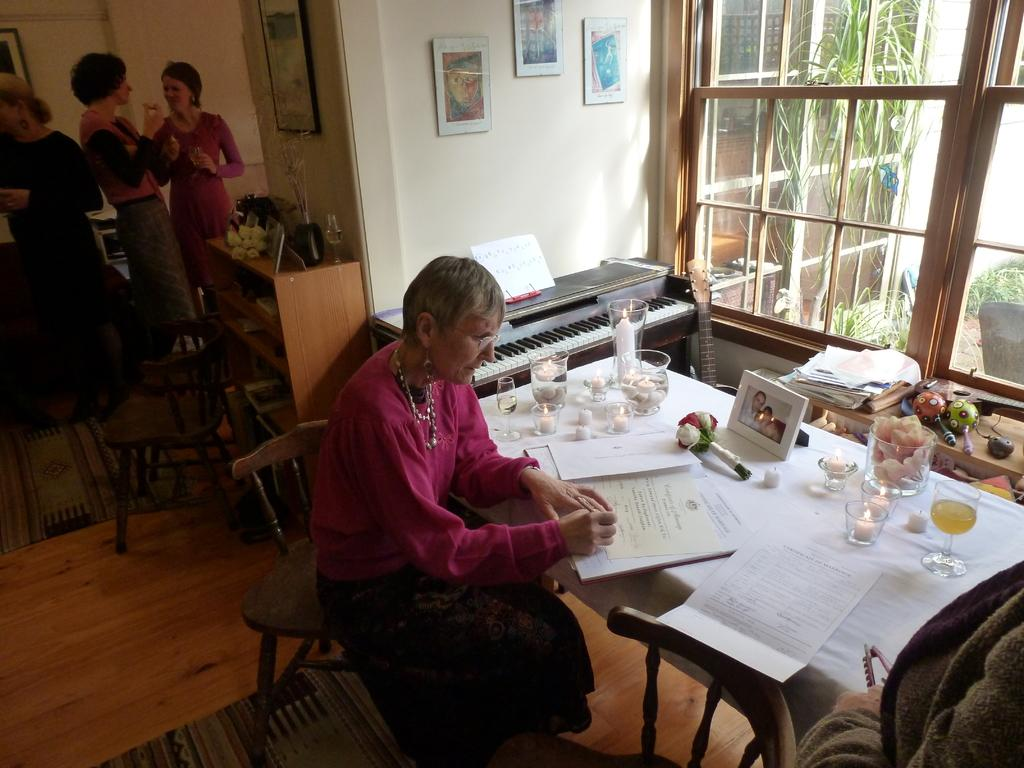What is the old woman in the image doing? The old woman is sitting and writing in the image. What objects are on the table in the image? There are candles, flowers, a book, and a photo frame on the table in the image. How many women are standing behind the old woman? There is a group of women standing behind the old woman. What type of patch is being sewn by the laborer in the image? There is no laborer or patch present in the image. 